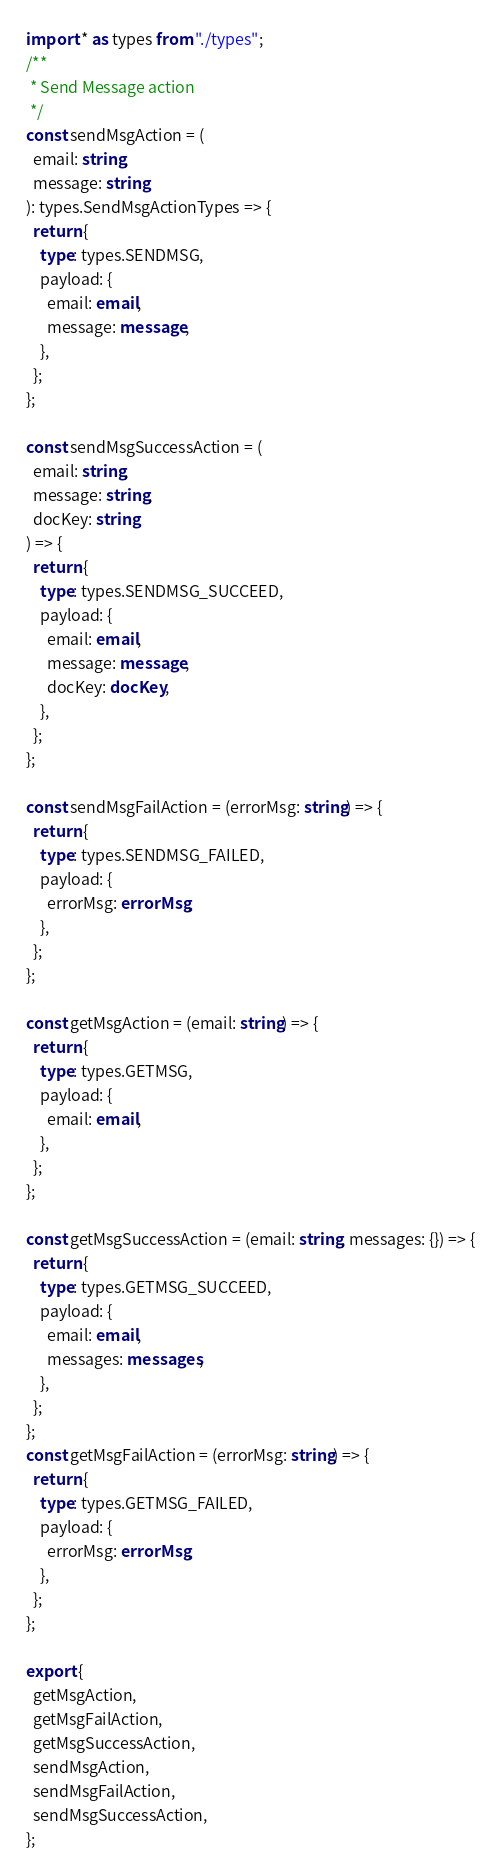<code> <loc_0><loc_0><loc_500><loc_500><_TypeScript_>import * as types from "./types";
/**
 * Send Message action
 */
const sendMsgAction = (
  email: string,
  message: string
): types.SendMsgActionTypes => {
  return {
    type: types.SENDMSG,
    payload: {
      email: email,
      message: message,
    },
  };
};

const sendMsgSuccessAction = (
  email: string,
  message: string,
  docKey: string
) => {
  return {
    type: types.SENDMSG_SUCCEED,
    payload: {
      email: email,
      message: message,
      docKey: docKey,
    },
  };
};

const sendMsgFailAction = (errorMsg: string) => {
  return {
    type: types.SENDMSG_FAILED,
    payload: {
      errorMsg: errorMsg,
    },
  };
};

const getMsgAction = (email: string) => {
  return {
    type: types.GETMSG,
    payload: {
      email: email,
    },
  };
};

const getMsgSuccessAction = (email: string, messages: {}) => {
  return {
    type: types.GETMSG_SUCCEED,
    payload: {
      email: email,
      messages: messages,
    },
  };
};
const getMsgFailAction = (errorMsg: string) => {
  return {
    type: types.GETMSG_FAILED,
    payload: {
      errorMsg: errorMsg,
    },
  };
};

export {
  getMsgAction,
  getMsgFailAction,
  getMsgSuccessAction,
  sendMsgAction,
  sendMsgFailAction,
  sendMsgSuccessAction,
};
</code> 